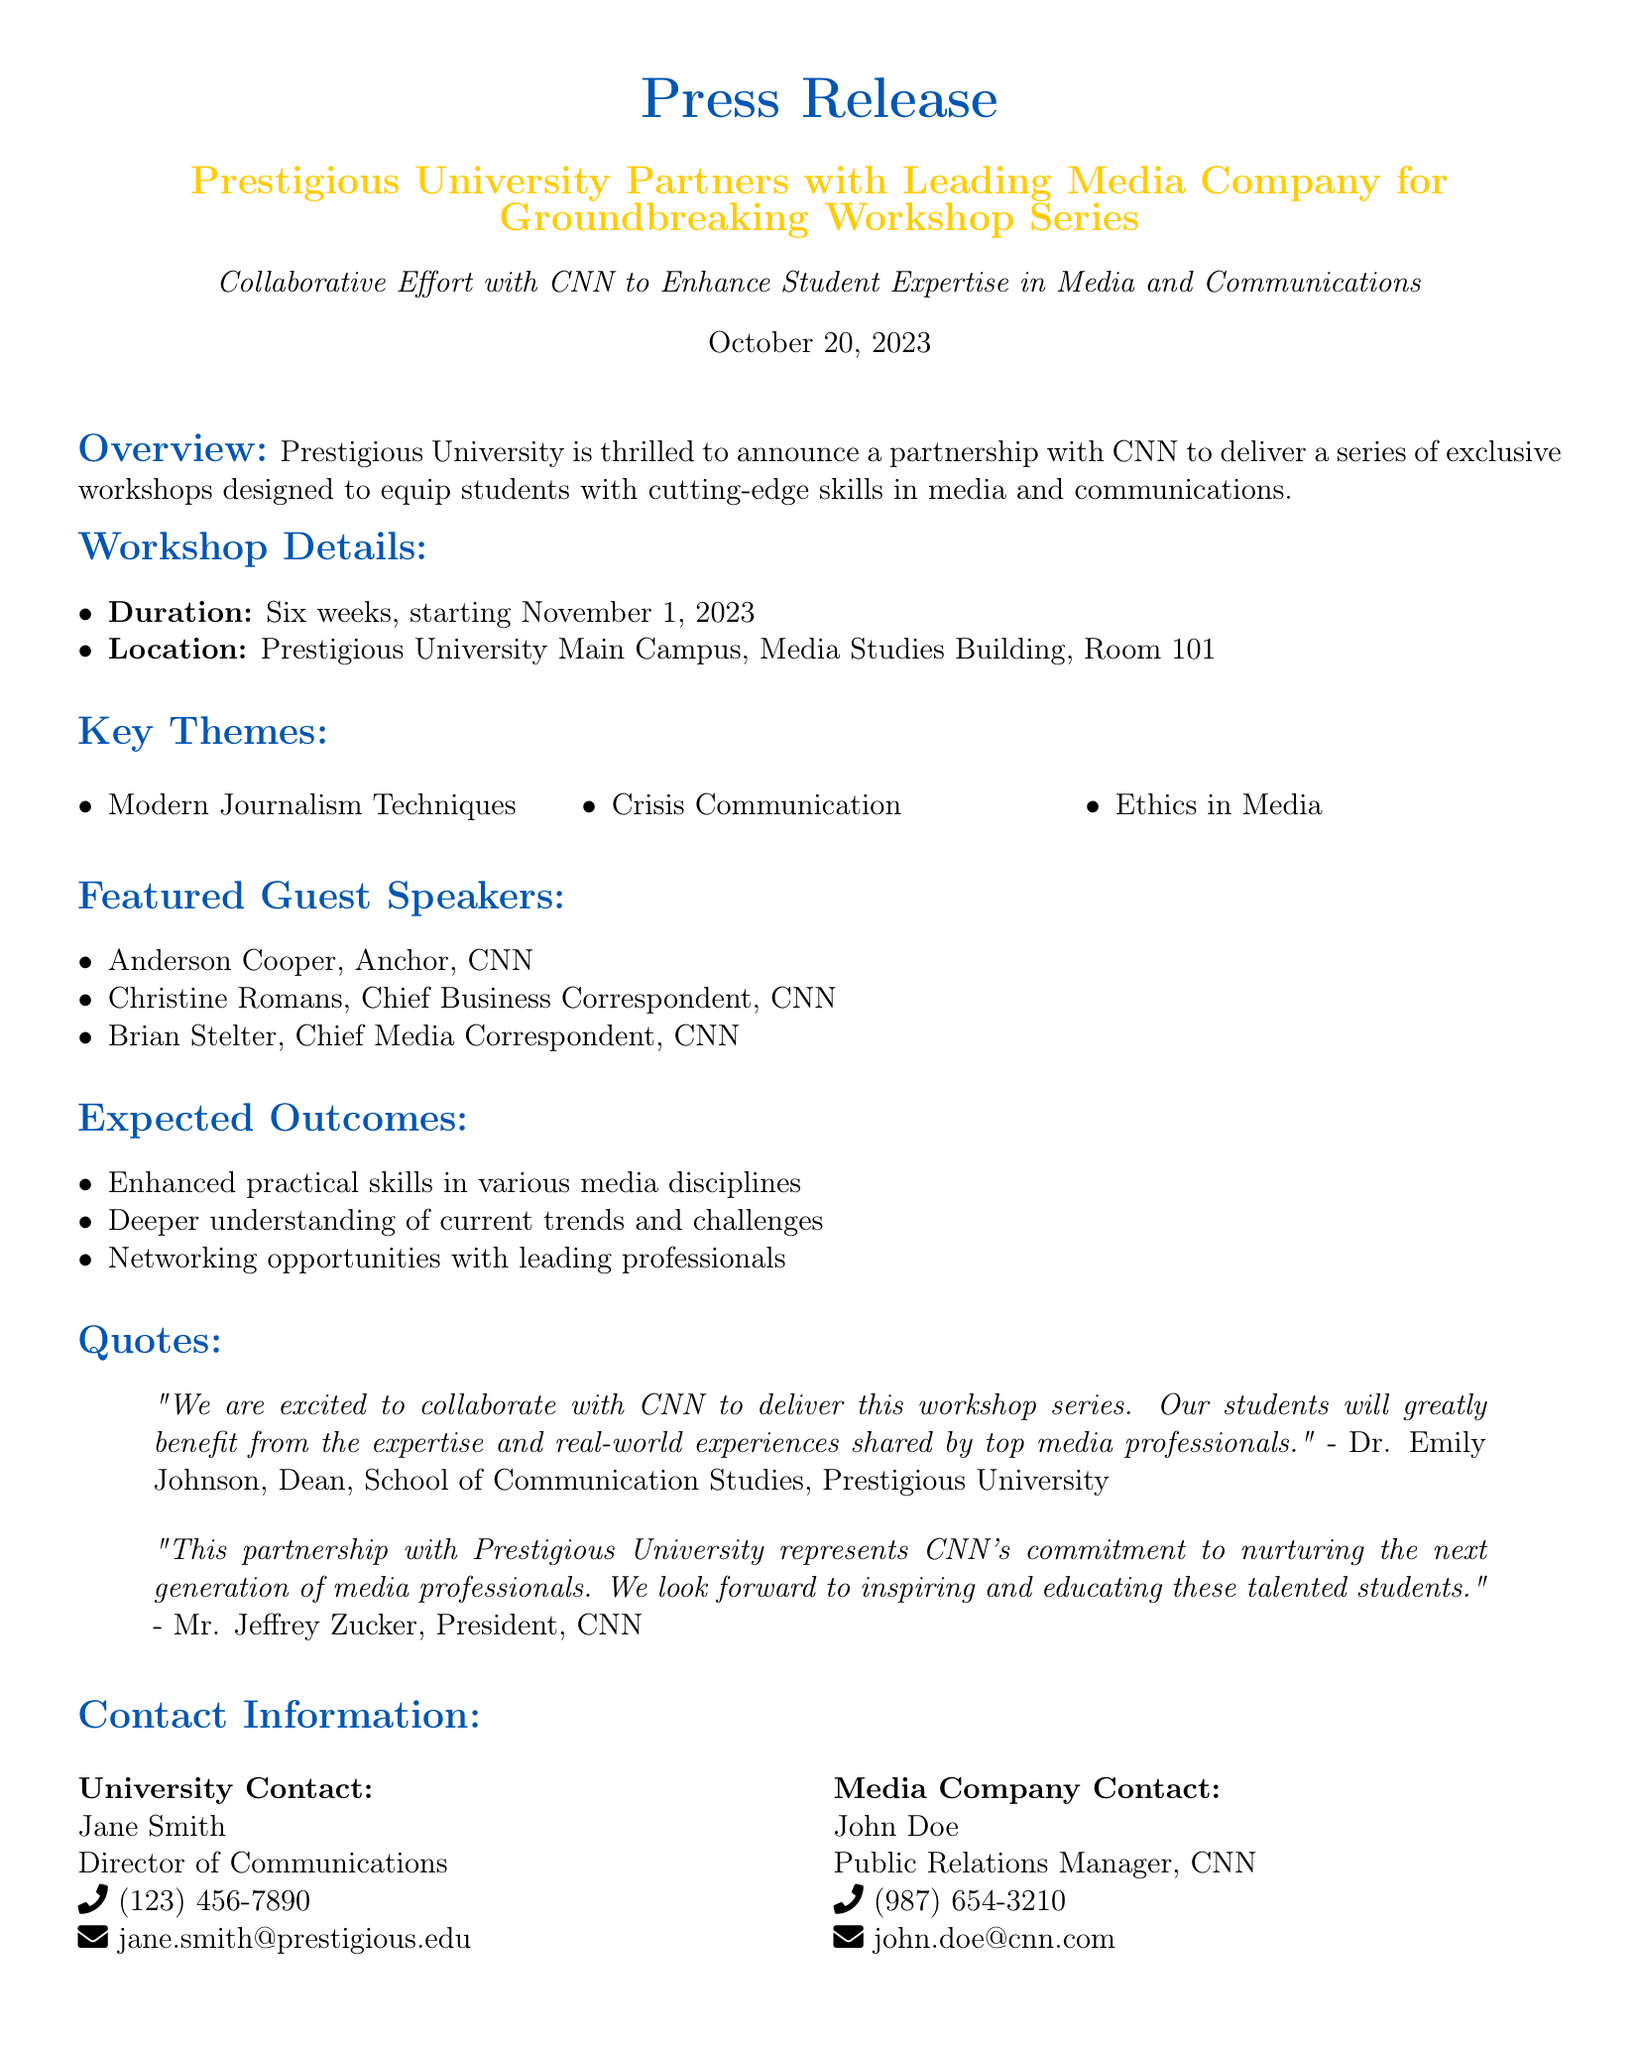What is the duration of the workshop series? The document states that the workshop series will last for six weeks, starting November 1, 2023.
Answer: Six weeks Who is the anchor from CNN participating in the workshops? The featured guest speakers section lists Anderson Cooper as the anchor, highlighting his participation in the workshops.
Answer: Anderson Cooper What is the location of the workshops? The press release specifies that the workshops will take place at the Prestigious University Main Campus, Media Studies Building, Room 101.
Answer: Media Studies Building, Room 101 What is one theme covered in the workshop series? Among the key themes listed in the document, one is "Crisis Communication," showcasing the topics to be discussed in the workshops.
Answer: Crisis Communication Who is the President of CNN quoted in the press release? The document includes a quote from Mr. Jeffrey Zucker, identifying him as the President of CNN.
Answer: Mr. Jeffrey Zucker What is an expected outcome of the workshop series? The expected outcomes include networking opportunities with leading professionals, as mentioned in the relevant section of the document.
Answer: Networking opportunities What date do the workshops start? The press release mentions that the workshops will begin on November 1, 2023, indicating the starting date clearly.
Answer: November 1, 2023 What is the title of the press release? The title of the press release is “Prestigious University Partners with Leading Media Company for Groundbreaking Workshop Series,” highlighting the collaboration.
Answer: Prestigious University Partners with Leading Media Company for Groundbreaking Workshop Series Who is the Director of Communications at the university? The contact information section lists Jane Smith as the Director of Communications at the university, providing her name and title.
Answer: Jane Smith 